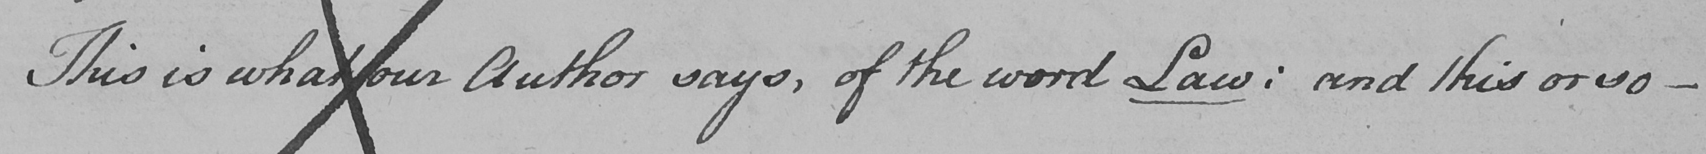Please provide the text content of this handwritten line. This is what our Author says , of the word Law :  and this or so  _ 